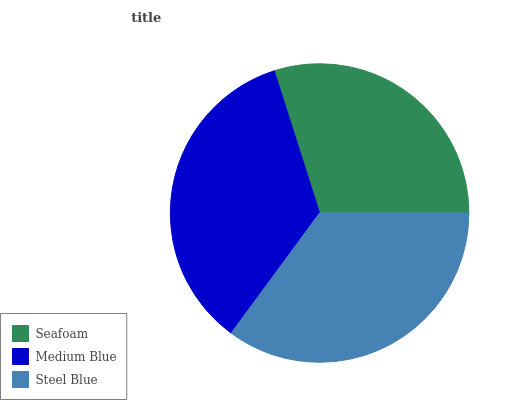Is Seafoam the minimum?
Answer yes or no. Yes. Is Steel Blue the maximum?
Answer yes or no. Yes. Is Medium Blue the minimum?
Answer yes or no. No. Is Medium Blue the maximum?
Answer yes or no. No. Is Medium Blue greater than Seafoam?
Answer yes or no. Yes. Is Seafoam less than Medium Blue?
Answer yes or no. Yes. Is Seafoam greater than Medium Blue?
Answer yes or no. No. Is Medium Blue less than Seafoam?
Answer yes or no. No. Is Medium Blue the high median?
Answer yes or no. Yes. Is Medium Blue the low median?
Answer yes or no. Yes. Is Seafoam the high median?
Answer yes or no. No. Is Seafoam the low median?
Answer yes or no. No. 